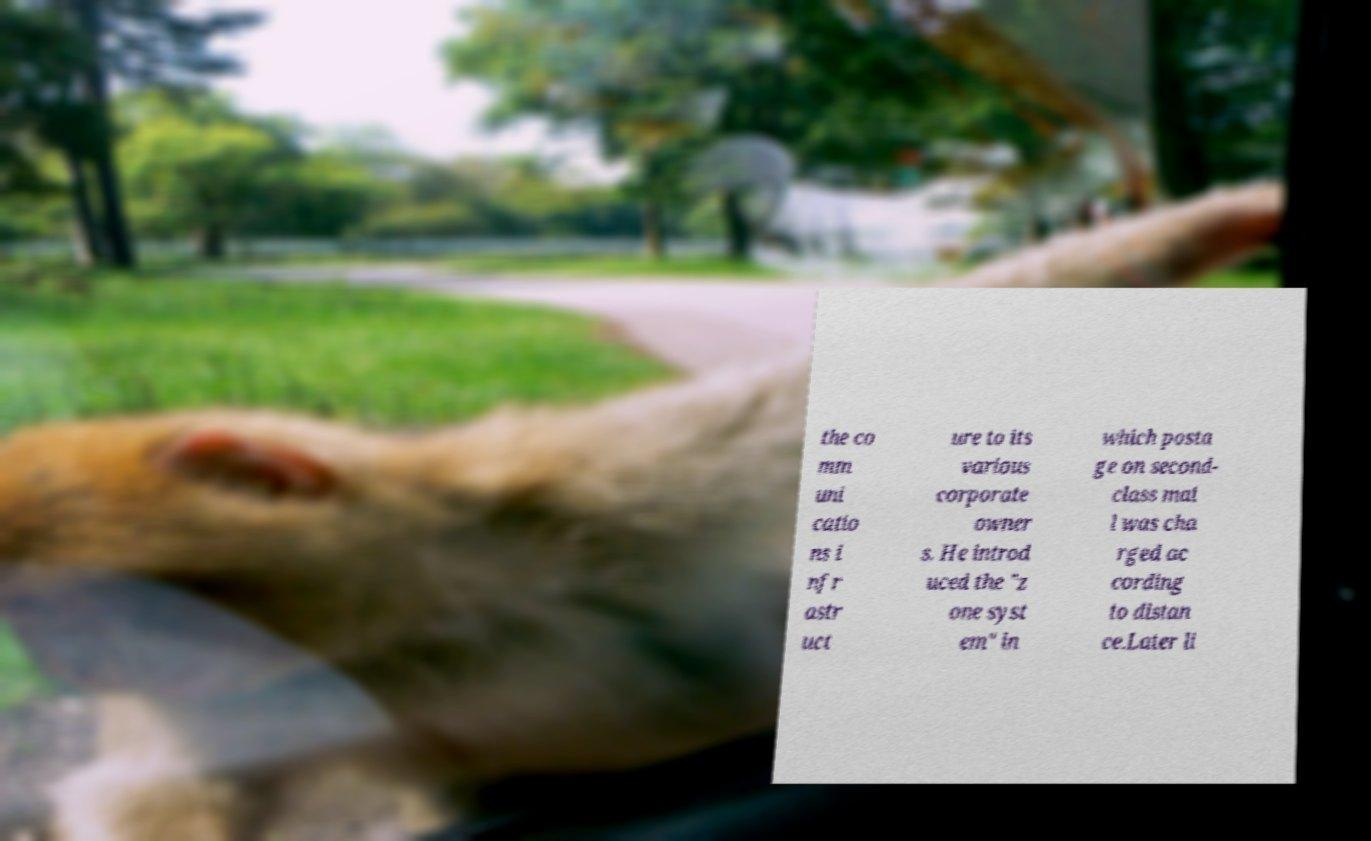Could you assist in decoding the text presented in this image and type it out clearly? the co mm uni catio ns i nfr astr uct ure to its various corporate owner s. He introd uced the "z one syst em" in which posta ge on second- class mai l was cha rged ac cording to distan ce.Later li 